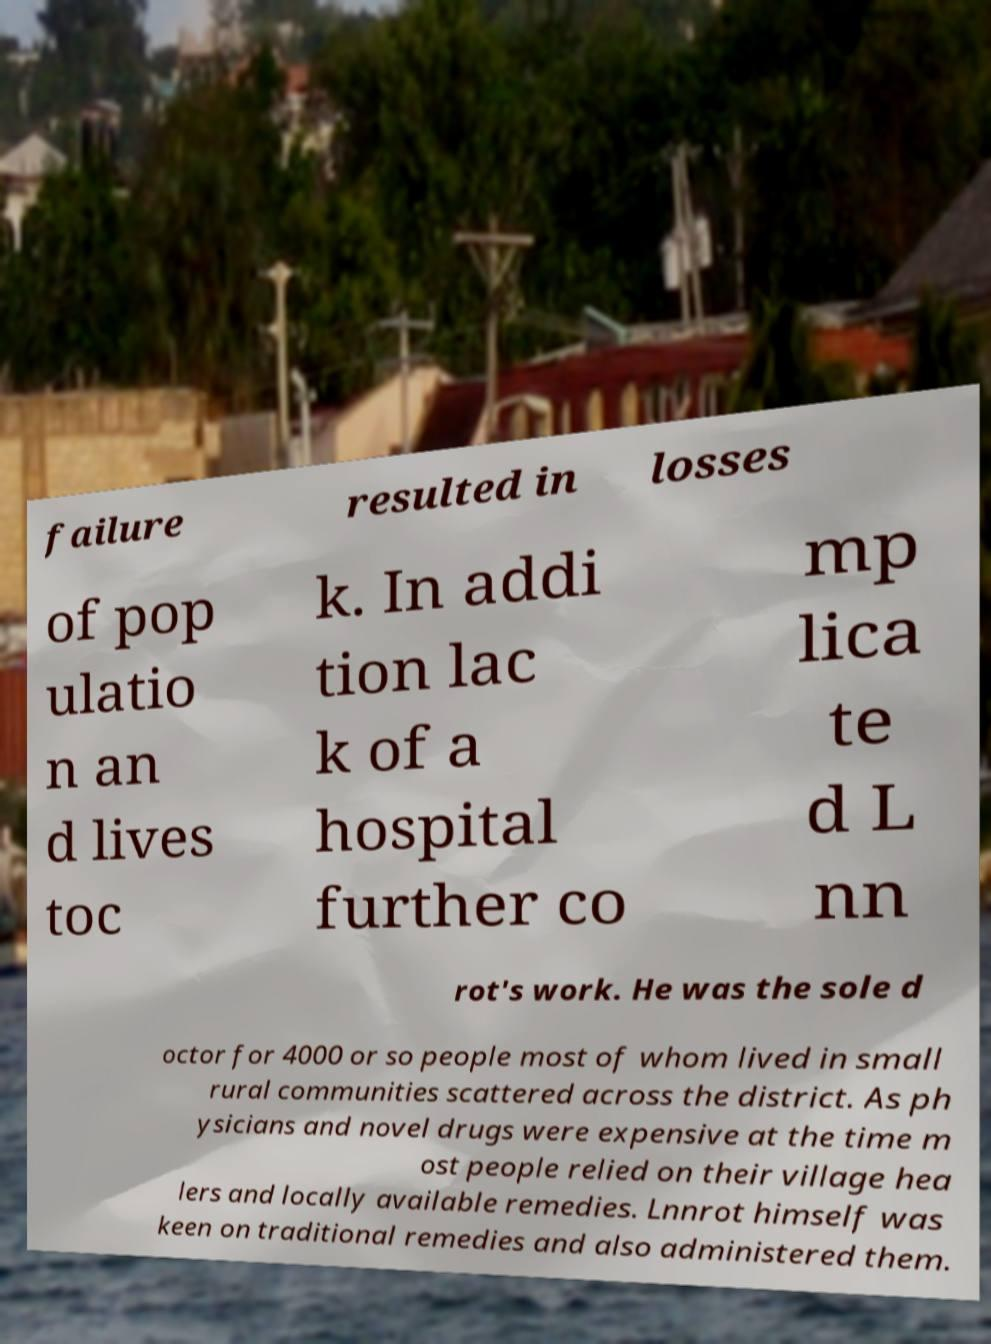For documentation purposes, I need the text within this image transcribed. Could you provide that? failure resulted in losses of pop ulatio n an d lives toc k. In addi tion lac k of a hospital further co mp lica te d L nn rot's work. He was the sole d octor for 4000 or so people most of whom lived in small rural communities scattered across the district. As ph ysicians and novel drugs were expensive at the time m ost people relied on their village hea lers and locally available remedies. Lnnrot himself was keen on traditional remedies and also administered them. 